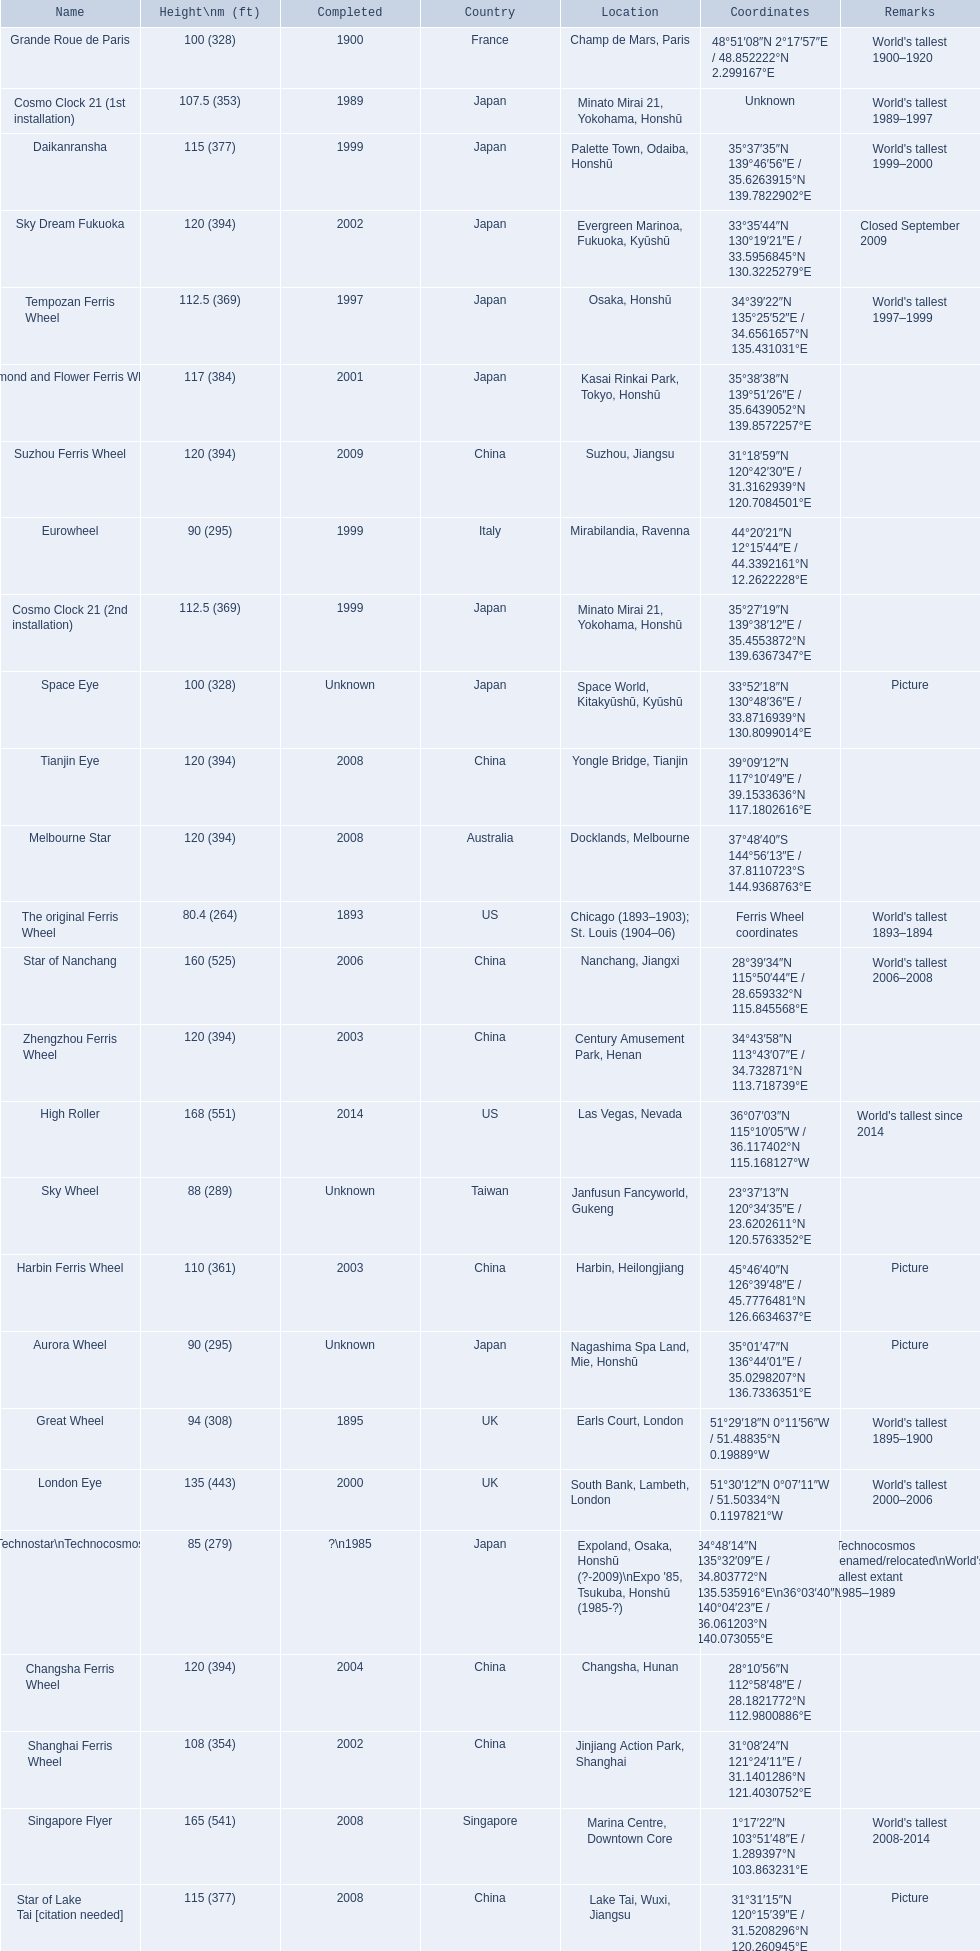What are all of the ferris wheels? High Roller, Singapore Flyer, Star of Nanchang, London Eye, Suzhou Ferris Wheel, Melbourne Star, Tianjin Eye, Changsha Ferris Wheel, Zhengzhou Ferris Wheel, Sky Dream Fukuoka, Diamond and Flower Ferris Wheel, Star of Lake Tai [citation needed], Daikanransha, Cosmo Clock 21 (2nd installation), Tempozan Ferris Wheel, Harbin Ferris Wheel, Shanghai Ferris Wheel, Cosmo Clock 21 (1st installation), Space Eye, Grande Roue de Paris, Great Wheel, Aurora Wheel, Eurowheel, Sky Wheel, Technostar\nTechnocosmos, The original Ferris Wheel. And when were they completed? 2014, 2008, 2006, 2000, 2009, 2008, 2008, 2004, 2003, 2002, 2001, 2008, 1999, 1999, 1997, 2003, 2002, 1989, Unknown, 1900, 1895, Unknown, 1999, Unknown, ?\n1985, 1893. And among star of lake tai, star of nanchang, and melbourne star, which ferris wheel is oldest? Star of Nanchang. 